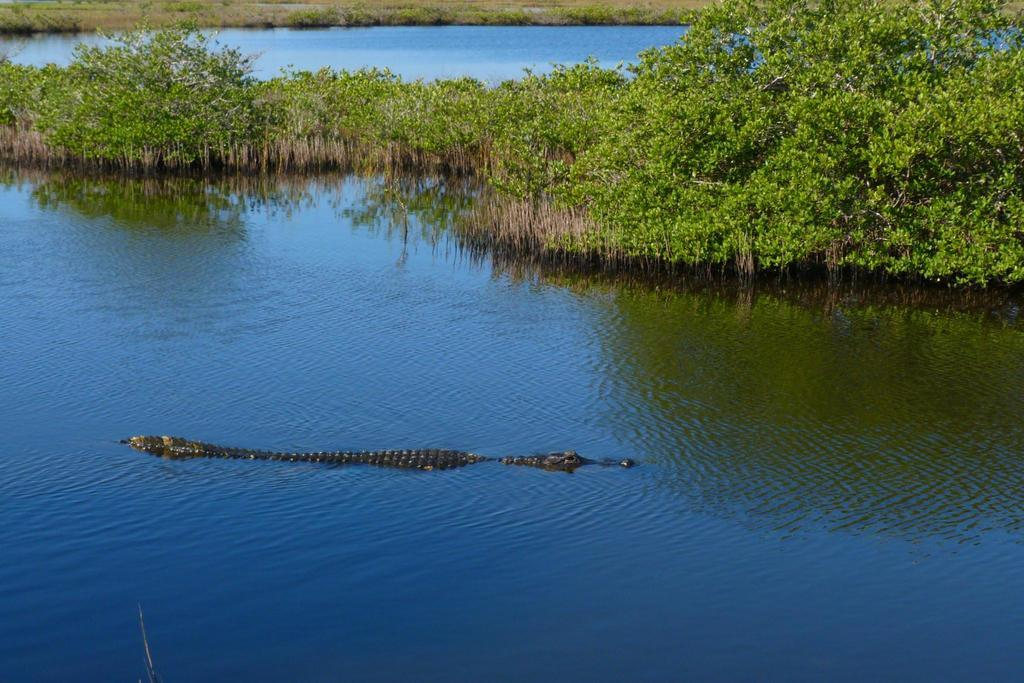What animal can be seen in the water in the image? There is a crocodile in the water in the image. What type of vegetation is visible in the image? There are trees and plants visible in the image. What type of ground cover can be seen in the background of the image? There is grass visible in the background of the image. What type of waves can be seen in the image? There are no waves visible in the image, as it features a crocodile in the water and not a body of water with waves. 